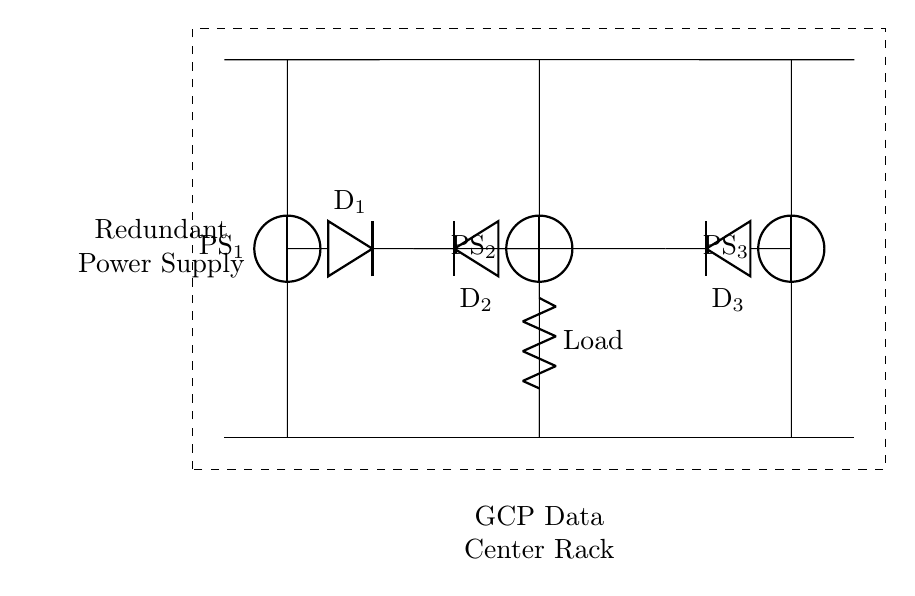What type of circuit is depicted in the diagram? The diagram represents a parallel circuit configuration where multiple power supplies are connected in parallel to provide redundancy for the load.
Answer: Parallel circuit How many power supplies are used in the circuit? Upon examining the diagram, there are three power supplies labeled PS1, PS2, and PS3, indicating that three power sources are utilized.
Answer: Three What is the purpose of the diodes in this circuit? The diodes serve as isolation devices to prevent backflow of current, thereby ensuring that if one power supply fails, the others can still supply power to the load without interfering with each other.
Answer: Isolation What is the total number of diodes used in this circuit? The diagram includes three diodes labeled D1, D2, and D3, each connected to its corresponding power supply for current isolation and proper operation in a parallel configuration.
Answer: Three What is the identified load in the circuit? The load in the circuit is connected at the center of the diagram and is visibly labeled, indicating it is the component that receives power from the power supplies.
Answer: Load If one power supply fails, will the load still receive power? Yes, the parallel configuration and the presence of diodes ensure that if one power supply fails, the remaining operational supplies can still deliver power to the load.
Answer: Yes What component connects the three power supplies to the load? The load is connected directly to the node where the output of the parallel power supplies converge, allowing all supplies to feed into the single load.
Answer: Node 